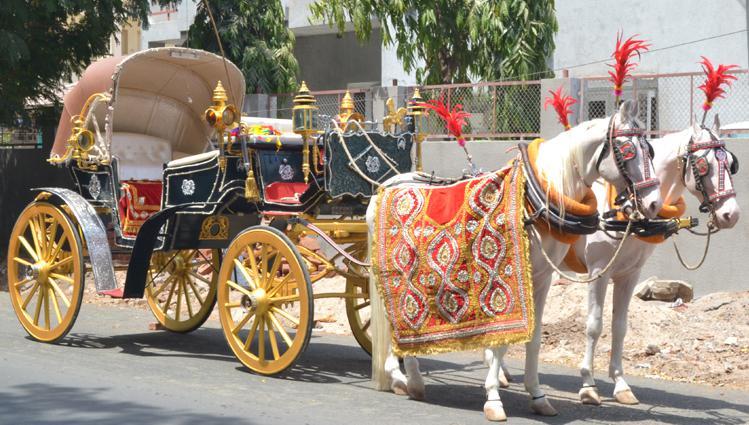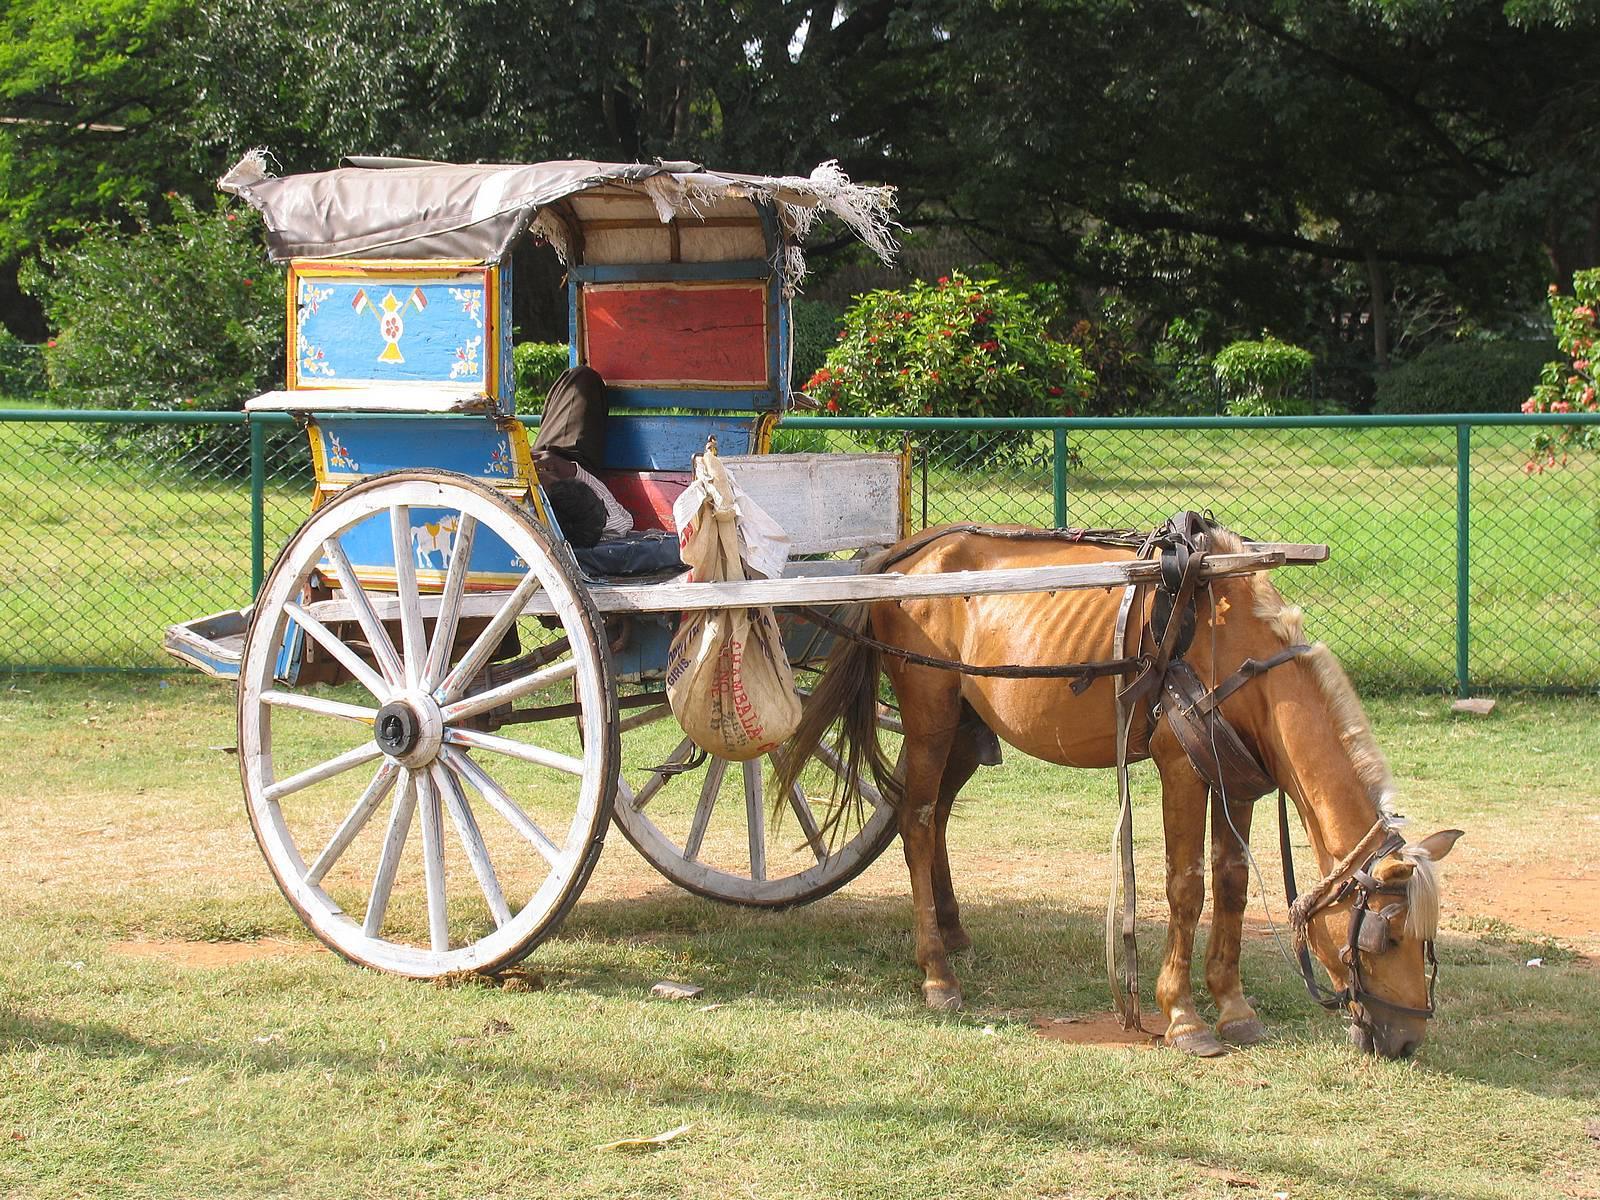The first image is the image on the left, the second image is the image on the right. For the images displayed, is the sentence "The image on the ride has a horse with a red tassel on its head." factually correct? Answer yes or no. No. The first image is the image on the left, the second image is the image on the right. Given the left and right images, does the statement "There is only one person riding in the cart in one of the images." hold true? Answer yes or no. No. 